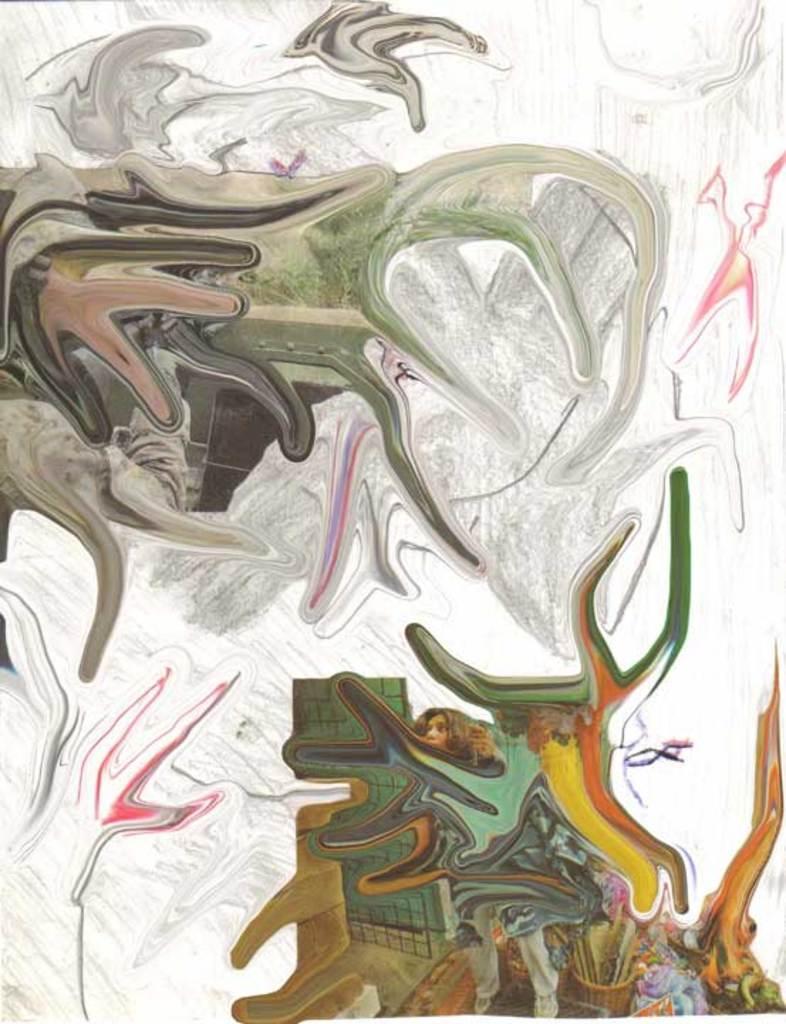Could you give a brief overview of what you see in this image? This is a painting. In this picture we can see the face and legs of a person on the right side. There are a few colorful things visible in it. 